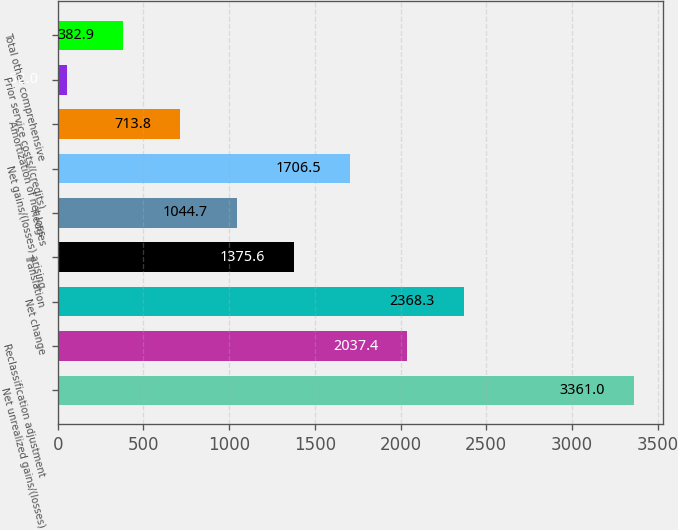Convert chart to OTSL. <chart><loc_0><loc_0><loc_500><loc_500><bar_chart><fcel>Net unrealized gains/(losses)<fcel>Reclassification adjustment<fcel>Net change<fcel>Translation<fcel>Hedges<fcel>Net gains/(losses) arising<fcel>Amortization of net loss<fcel>Prior service costs/(credits)<fcel>Total other comprehensive<nl><fcel>3361<fcel>2037.4<fcel>2368.3<fcel>1375.6<fcel>1044.7<fcel>1706.5<fcel>713.8<fcel>52<fcel>382.9<nl></chart> 